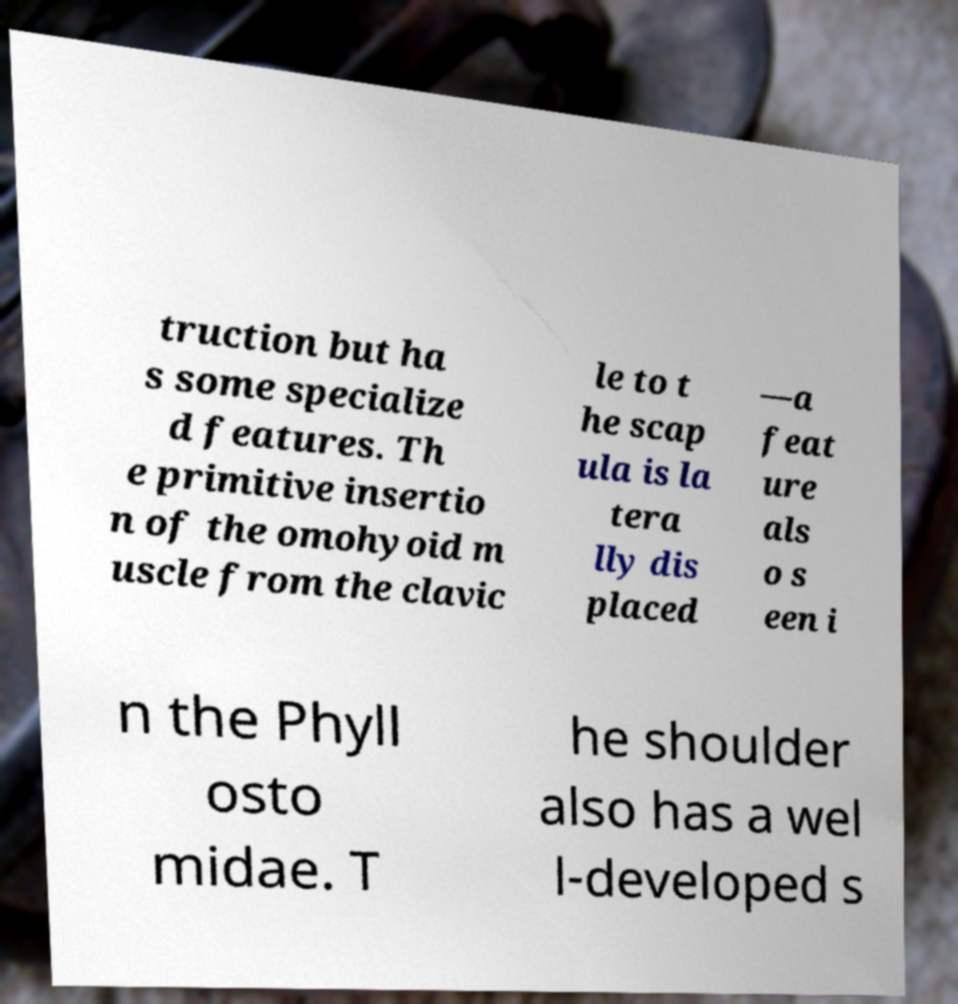Can you accurately transcribe the text from the provided image for me? truction but ha s some specialize d features. Th e primitive insertio n of the omohyoid m uscle from the clavic le to t he scap ula is la tera lly dis placed —a feat ure als o s een i n the Phyll osto midae. T he shoulder also has a wel l-developed s 